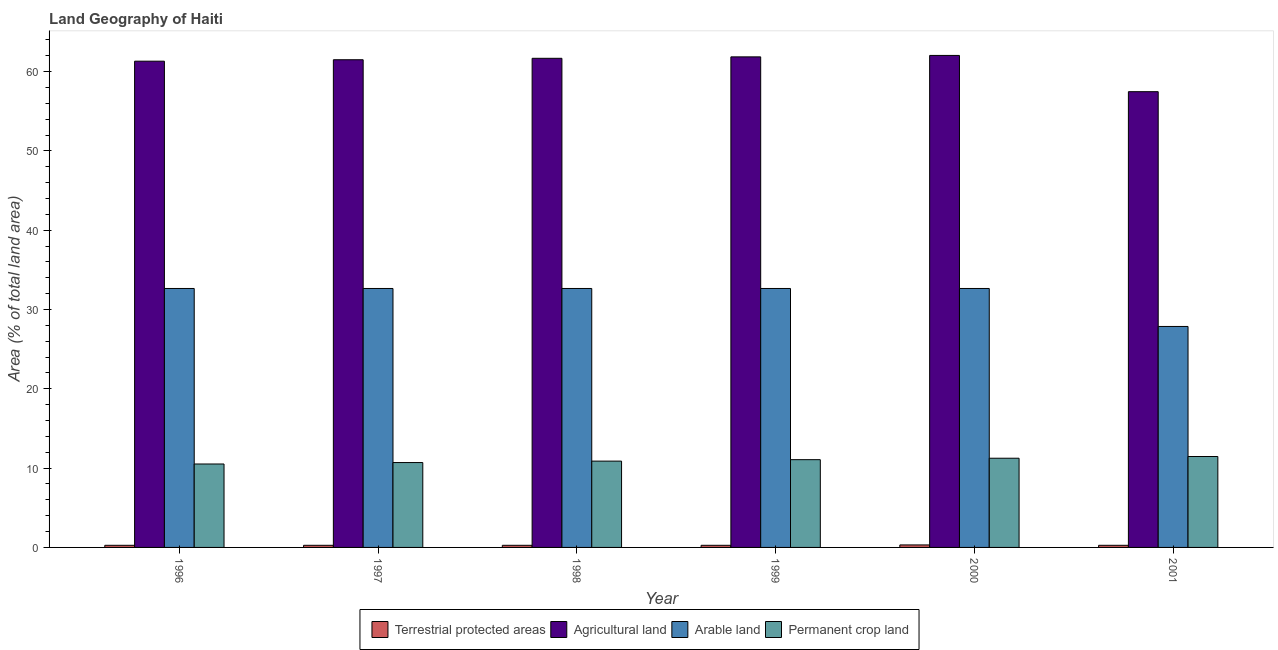How many different coloured bars are there?
Your answer should be very brief. 4. How many bars are there on the 2nd tick from the left?
Provide a short and direct response. 4. How many bars are there on the 5th tick from the right?
Provide a short and direct response. 4. In how many cases, is the number of bars for a given year not equal to the number of legend labels?
Your answer should be very brief. 0. What is the percentage of area under arable land in 1996?
Provide a short and direct response. 32.66. Across all years, what is the maximum percentage of area under agricultural land?
Make the answer very short. 62.05. Across all years, what is the minimum percentage of area under agricultural land?
Provide a succinct answer. 57.47. In which year was the percentage of area under agricultural land maximum?
Your answer should be compact. 2000. In which year was the percentage of land under terrestrial protection minimum?
Provide a succinct answer. 1996. What is the total percentage of land under terrestrial protection in the graph?
Give a very brief answer. 1.66. What is the difference between the percentage of area under permanent crop land in 1999 and that in 2000?
Give a very brief answer. -0.18. What is the difference between the percentage of area under permanent crop land in 1997 and the percentage of area under agricultural land in 2001?
Your response must be concise. -0.76. What is the average percentage of area under arable land per year?
Offer a terse response. 31.86. What is the ratio of the percentage of area under permanent crop land in 1997 to that in 2001?
Provide a short and direct response. 0.93. Is the percentage of land under terrestrial protection in 1996 less than that in 1998?
Provide a succinct answer. No. Is the difference between the percentage of area under arable land in 1999 and 2000 greater than the difference between the percentage of area under permanent crop land in 1999 and 2000?
Keep it short and to the point. No. What is the difference between the highest and the second highest percentage of area under arable land?
Keep it short and to the point. 0. What is the difference between the highest and the lowest percentage of area under arable land?
Give a very brief answer. 4.79. Is it the case that in every year, the sum of the percentage of area under permanent crop land and percentage of area under arable land is greater than the sum of percentage of area under agricultural land and percentage of land under terrestrial protection?
Provide a short and direct response. No. What does the 1st bar from the left in 1998 represents?
Keep it short and to the point. Terrestrial protected areas. What does the 1st bar from the right in 1997 represents?
Offer a terse response. Permanent crop land. Is it the case that in every year, the sum of the percentage of land under terrestrial protection and percentage of area under agricultural land is greater than the percentage of area under arable land?
Provide a succinct answer. Yes. Are all the bars in the graph horizontal?
Make the answer very short. No. What is the difference between two consecutive major ticks on the Y-axis?
Provide a succinct answer. 10. Does the graph contain any zero values?
Ensure brevity in your answer.  No. Does the graph contain grids?
Ensure brevity in your answer.  No. Where does the legend appear in the graph?
Ensure brevity in your answer.  Bottom center. What is the title of the graph?
Offer a very short reply. Land Geography of Haiti. Does "Others" appear as one of the legend labels in the graph?
Your answer should be compact. No. What is the label or title of the Y-axis?
Ensure brevity in your answer.  Area (% of total land area). What is the Area (% of total land area) in Terrestrial protected areas in 1996?
Your answer should be compact. 0.27. What is the Area (% of total land area) in Agricultural land in 1996?
Provide a succinct answer. 61.32. What is the Area (% of total land area) of Arable land in 1996?
Provide a succinct answer. 32.66. What is the Area (% of total land area) of Permanent crop land in 1996?
Make the answer very short. 10.52. What is the Area (% of total land area) in Terrestrial protected areas in 1997?
Provide a succinct answer. 0.27. What is the Area (% of total land area) of Agricultural land in 1997?
Ensure brevity in your answer.  61.5. What is the Area (% of total land area) in Arable land in 1997?
Provide a succinct answer. 32.66. What is the Area (% of total land area) in Permanent crop land in 1997?
Offer a very short reply. 10.7. What is the Area (% of total land area) in Terrestrial protected areas in 1998?
Keep it short and to the point. 0.27. What is the Area (% of total land area) in Agricultural land in 1998?
Provide a short and direct response. 61.68. What is the Area (% of total land area) of Arable land in 1998?
Provide a succinct answer. 32.66. What is the Area (% of total land area) of Permanent crop land in 1998?
Offer a terse response. 10.89. What is the Area (% of total land area) of Terrestrial protected areas in 1999?
Make the answer very short. 0.27. What is the Area (% of total land area) of Agricultural land in 1999?
Offer a very short reply. 61.87. What is the Area (% of total land area) in Arable land in 1999?
Your response must be concise. 32.66. What is the Area (% of total land area) in Permanent crop land in 1999?
Offer a very short reply. 11.07. What is the Area (% of total land area) in Terrestrial protected areas in 2000?
Keep it short and to the point. 0.32. What is the Area (% of total land area) in Agricultural land in 2000?
Provide a short and direct response. 62.05. What is the Area (% of total land area) of Arable land in 2000?
Make the answer very short. 32.66. What is the Area (% of total land area) of Permanent crop land in 2000?
Ensure brevity in your answer.  11.25. What is the Area (% of total land area) in Terrestrial protected areas in 2001?
Ensure brevity in your answer.  0.27. What is the Area (% of total land area) of Agricultural land in 2001?
Provide a succinct answer. 57.47. What is the Area (% of total land area) in Arable land in 2001?
Offer a terse response. 27.87. What is the Area (% of total land area) in Permanent crop land in 2001?
Your answer should be very brief. 11.47. Across all years, what is the maximum Area (% of total land area) of Terrestrial protected areas?
Provide a short and direct response. 0.32. Across all years, what is the maximum Area (% of total land area) in Agricultural land?
Provide a short and direct response. 62.05. Across all years, what is the maximum Area (% of total land area) in Arable land?
Give a very brief answer. 32.66. Across all years, what is the maximum Area (% of total land area) in Permanent crop land?
Your answer should be compact. 11.47. Across all years, what is the minimum Area (% of total land area) in Terrestrial protected areas?
Keep it short and to the point. 0.27. Across all years, what is the minimum Area (% of total land area) in Agricultural land?
Provide a succinct answer. 57.47. Across all years, what is the minimum Area (% of total land area) of Arable land?
Provide a short and direct response. 27.87. Across all years, what is the minimum Area (% of total land area) in Permanent crop land?
Offer a very short reply. 10.52. What is the total Area (% of total land area) of Terrestrial protected areas in the graph?
Ensure brevity in your answer.  1.66. What is the total Area (% of total land area) in Agricultural land in the graph?
Your answer should be compact. 365.89. What is the total Area (% of total land area) in Arable land in the graph?
Offer a terse response. 191.15. What is the total Area (% of total land area) in Permanent crop land in the graph?
Offer a very short reply. 65.89. What is the difference between the Area (% of total land area) of Agricultural land in 1996 and that in 1997?
Provide a succinct answer. -0.18. What is the difference between the Area (% of total land area) of Arable land in 1996 and that in 1997?
Keep it short and to the point. 0. What is the difference between the Area (% of total land area) in Permanent crop land in 1996 and that in 1997?
Ensure brevity in your answer.  -0.18. What is the difference between the Area (% of total land area) of Terrestrial protected areas in 1996 and that in 1998?
Make the answer very short. 0. What is the difference between the Area (% of total land area) in Agricultural land in 1996 and that in 1998?
Provide a short and direct response. -0.36. What is the difference between the Area (% of total land area) in Permanent crop land in 1996 and that in 1998?
Your response must be concise. -0.36. What is the difference between the Area (% of total land area) of Agricultural land in 1996 and that in 1999?
Give a very brief answer. -0.54. What is the difference between the Area (% of total land area) in Arable land in 1996 and that in 1999?
Give a very brief answer. 0. What is the difference between the Area (% of total land area) of Permanent crop land in 1996 and that in 1999?
Make the answer very short. -0.54. What is the difference between the Area (% of total land area) of Terrestrial protected areas in 1996 and that in 2000?
Provide a short and direct response. -0.05. What is the difference between the Area (% of total land area) in Agricultural land in 1996 and that in 2000?
Provide a succinct answer. -0.73. What is the difference between the Area (% of total land area) in Permanent crop land in 1996 and that in 2000?
Provide a short and direct response. -0.73. What is the difference between the Area (% of total land area) of Terrestrial protected areas in 1996 and that in 2001?
Provide a short and direct response. 0. What is the difference between the Area (% of total land area) in Agricultural land in 1996 and that in 2001?
Keep it short and to the point. 3.85. What is the difference between the Area (% of total land area) of Arable land in 1996 and that in 2001?
Your answer should be compact. 4.79. What is the difference between the Area (% of total land area) in Permanent crop land in 1996 and that in 2001?
Provide a succinct answer. -0.94. What is the difference between the Area (% of total land area) in Agricultural land in 1997 and that in 1998?
Make the answer very short. -0.18. What is the difference between the Area (% of total land area) of Arable land in 1997 and that in 1998?
Offer a terse response. 0. What is the difference between the Area (% of total land area) of Permanent crop land in 1997 and that in 1998?
Provide a short and direct response. -0.18. What is the difference between the Area (% of total land area) in Agricultural land in 1997 and that in 1999?
Offer a very short reply. -0.36. What is the difference between the Area (% of total land area) of Permanent crop land in 1997 and that in 1999?
Offer a very short reply. -0.36. What is the difference between the Area (% of total land area) of Terrestrial protected areas in 1997 and that in 2000?
Your response must be concise. -0.05. What is the difference between the Area (% of total land area) of Agricultural land in 1997 and that in 2000?
Keep it short and to the point. -0.54. What is the difference between the Area (% of total land area) of Arable land in 1997 and that in 2000?
Provide a short and direct response. 0. What is the difference between the Area (% of total land area) of Permanent crop land in 1997 and that in 2000?
Your response must be concise. -0.54. What is the difference between the Area (% of total land area) of Agricultural land in 1997 and that in 2001?
Offer a very short reply. 4.03. What is the difference between the Area (% of total land area) of Arable land in 1997 and that in 2001?
Offer a terse response. 4.79. What is the difference between the Area (% of total land area) in Permanent crop land in 1997 and that in 2001?
Keep it short and to the point. -0.76. What is the difference between the Area (% of total land area) in Agricultural land in 1998 and that in 1999?
Ensure brevity in your answer.  -0.18. What is the difference between the Area (% of total land area) in Permanent crop land in 1998 and that in 1999?
Provide a short and direct response. -0.18. What is the difference between the Area (% of total land area) in Terrestrial protected areas in 1998 and that in 2000?
Provide a short and direct response. -0.05. What is the difference between the Area (% of total land area) of Agricultural land in 1998 and that in 2000?
Ensure brevity in your answer.  -0.36. What is the difference between the Area (% of total land area) of Arable land in 1998 and that in 2000?
Provide a short and direct response. 0. What is the difference between the Area (% of total land area) of Permanent crop land in 1998 and that in 2000?
Offer a terse response. -0.36. What is the difference between the Area (% of total land area) in Agricultural land in 1998 and that in 2001?
Provide a succinct answer. 4.21. What is the difference between the Area (% of total land area) of Arable land in 1998 and that in 2001?
Keep it short and to the point. 4.79. What is the difference between the Area (% of total land area) of Permanent crop land in 1998 and that in 2001?
Provide a succinct answer. -0.58. What is the difference between the Area (% of total land area) in Terrestrial protected areas in 1999 and that in 2000?
Give a very brief answer. -0.05. What is the difference between the Area (% of total land area) of Agricultural land in 1999 and that in 2000?
Your answer should be compact. -0.18. What is the difference between the Area (% of total land area) of Permanent crop land in 1999 and that in 2000?
Ensure brevity in your answer.  -0.18. What is the difference between the Area (% of total land area) of Agricultural land in 1999 and that in 2001?
Give a very brief answer. 4.39. What is the difference between the Area (% of total land area) in Arable land in 1999 and that in 2001?
Keep it short and to the point. 4.79. What is the difference between the Area (% of total land area) in Permanent crop land in 1999 and that in 2001?
Your answer should be very brief. -0.4. What is the difference between the Area (% of total land area) of Terrestrial protected areas in 2000 and that in 2001?
Provide a short and direct response. 0.05. What is the difference between the Area (% of total land area) of Agricultural land in 2000 and that in 2001?
Make the answer very short. 4.57. What is the difference between the Area (% of total land area) of Arable land in 2000 and that in 2001?
Ensure brevity in your answer.  4.79. What is the difference between the Area (% of total land area) of Permanent crop land in 2000 and that in 2001?
Your answer should be very brief. -0.22. What is the difference between the Area (% of total land area) in Terrestrial protected areas in 1996 and the Area (% of total land area) in Agricultural land in 1997?
Your response must be concise. -61.23. What is the difference between the Area (% of total land area) of Terrestrial protected areas in 1996 and the Area (% of total land area) of Arable land in 1997?
Provide a short and direct response. -32.39. What is the difference between the Area (% of total land area) of Terrestrial protected areas in 1996 and the Area (% of total land area) of Permanent crop land in 1997?
Offer a very short reply. -10.44. What is the difference between the Area (% of total land area) in Agricultural land in 1996 and the Area (% of total land area) in Arable land in 1997?
Make the answer very short. 28.66. What is the difference between the Area (% of total land area) of Agricultural land in 1996 and the Area (% of total land area) of Permanent crop land in 1997?
Your response must be concise. 50.62. What is the difference between the Area (% of total land area) of Arable land in 1996 and the Area (% of total land area) of Permanent crop land in 1997?
Your answer should be very brief. 21.95. What is the difference between the Area (% of total land area) in Terrestrial protected areas in 1996 and the Area (% of total land area) in Agricultural land in 1998?
Offer a very short reply. -61.42. What is the difference between the Area (% of total land area) in Terrestrial protected areas in 1996 and the Area (% of total land area) in Arable land in 1998?
Ensure brevity in your answer.  -32.39. What is the difference between the Area (% of total land area) of Terrestrial protected areas in 1996 and the Area (% of total land area) of Permanent crop land in 1998?
Keep it short and to the point. -10.62. What is the difference between the Area (% of total land area) in Agricultural land in 1996 and the Area (% of total land area) in Arable land in 1998?
Your answer should be compact. 28.66. What is the difference between the Area (% of total land area) of Agricultural land in 1996 and the Area (% of total land area) of Permanent crop land in 1998?
Your answer should be compact. 50.44. What is the difference between the Area (% of total land area) in Arable land in 1996 and the Area (% of total land area) in Permanent crop land in 1998?
Offer a very short reply. 21.77. What is the difference between the Area (% of total land area) in Terrestrial protected areas in 1996 and the Area (% of total land area) in Agricultural land in 1999?
Offer a very short reply. -61.6. What is the difference between the Area (% of total land area) of Terrestrial protected areas in 1996 and the Area (% of total land area) of Arable land in 1999?
Keep it short and to the point. -32.39. What is the difference between the Area (% of total land area) of Terrestrial protected areas in 1996 and the Area (% of total land area) of Permanent crop land in 1999?
Ensure brevity in your answer.  -10.8. What is the difference between the Area (% of total land area) in Agricultural land in 1996 and the Area (% of total land area) in Arable land in 1999?
Provide a short and direct response. 28.66. What is the difference between the Area (% of total land area) of Agricultural land in 1996 and the Area (% of total land area) of Permanent crop land in 1999?
Make the answer very short. 50.25. What is the difference between the Area (% of total land area) in Arable land in 1996 and the Area (% of total land area) in Permanent crop land in 1999?
Offer a very short reply. 21.59. What is the difference between the Area (% of total land area) in Terrestrial protected areas in 1996 and the Area (% of total land area) in Agricultural land in 2000?
Give a very brief answer. -61.78. What is the difference between the Area (% of total land area) in Terrestrial protected areas in 1996 and the Area (% of total land area) in Arable land in 2000?
Give a very brief answer. -32.39. What is the difference between the Area (% of total land area) of Terrestrial protected areas in 1996 and the Area (% of total land area) of Permanent crop land in 2000?
Provide a succinct answer. -10.98. What is the difference between the Area (% of total land area) of Agricultural land in 1996 and the Area (% of total land area) of Arable land in 2000?
Provide a succinct answer. 28.66. What is the difference between the Area (% of total land area) in Agricultural land in 1996 and the Area (% of total land area) in Permanent crop land in 2000?
Provide a short and direct response. 50.07. What is the difference between the Area (% of total land area) in Arable land in 1996 and the Area (% of total land area) in Permanent crop land in 2000?
Make the answer very short. 21.41. What is the difference between the Area (% of total land area) of Terrestrial protected areas in 1996 and the Area (% of total land area) of Agricultural land in 2001?
Keep it short and to the point. -57.21. What is the difference between the Area (% of total land area) in Terrestrial protected areas in 1996 and the Area (% of total land area) in Arable land in 2001?
Give a very brief answer. -27.6. What is the difference between the Area (% of total land area) in Terrestrial protected areas in 1996 and the Area (% of total land area) in Permanent crop land in 2001?
Offer a very short reply. -11.2. What is the difference between the Area (% of total land area) in Agricultural land in 1996 and the Area (% of total land area) in Arable land in 2001?
Ensure brevity in your answer.  33.45. What is the difference between the Area (% of total land area) in Agricultural land in 1996 and the Area (% of total land area) in Permanent crop land in 2001?
Your answer should be very brief. 49.85. What is the difference between the Area (% of total land area) in Arable land in 1996 and the Area (% of total land area) in Permanent crop land in 2001?
Offer a terse response. 21.19. What is the difference between the Area (% of total land area) of Terrestrial protected areas in 1997 and the Area (% of total land area) of Agricultural land in 1998?
Your answer should be very brief. -61.42. What is the difference between the Area (% of total land area) of Terrestrial protected areas in 1997 and the Area (% of total land area) of Arable land in 1998?
Provide a short and direct response. -32.39. What is the difference between the Area (% of total land area) in Terrestrial protected areas in 1997 and the Area (% of total land area) in Permanent crop land in 1998?
Ensure brevity in your answer.  -10.62. What is the difference between the Area (% of total land area) of Agricultural land in 1997 and the Area (% of total land area) of Arable land in 1998?
Provide a short and direct response. 28.85. What is the difference between the Area (% of total land area) of Agricultural land in 1997 and the Area (% of total land area) of Permanent crop land in 1998?
Your answer should be very brief. 50.62. What is the difference between the Area (% of total land area) in Arable land in 1997 and the Area (% of total land area) in Permanent crop land in 1998?
Offer a very short reply. 21.77. What is the difference between the Area (% of total land area) in Terrestrial protected areas in 1997 and the Area (% of total land area) in Agricultural land in 1999?
Keep it short and to the point. -61.6. What is the difference between the Area (% of total land area) of Terrestrial protected areas in 1997 and the Area (% of total land area) of Arable land in 1999?
Give a very brief answer. -32.39. What is the difference between the Area (% of total land area) in Terrestrial protected areas in 1997 and the Area (% of total land area) in Permanent crop land in 1999?
Make the answer very short. -10.8. What is the difference between the Area (% of total land area) in Agricultural land in 1997 and the Area (% of total land area) in Arable land in 1999?
Your answer should be compact. 28.85. What is the difference between the Area (% of total land area) of Agricultural land in 1997 and the Area (% of total land area) of Permanent crop land in 1999?
Your answer should be very brief. 50.44. What is the difference between the Area (% of total land area) of Arable land in 1997 and the Area (% of total land area) of Permanent crop land in 1999?
Your answer should be compact. 21.59. What is the difference between the Area (% of total land area) of Terrestrial protected areas in 1997 and the Area (% of total land area) of Agricultural land in 2000?
Provide a succinct answer. -61.78. What is the difference between the Area (% of total land area) in Terrestrial protected areas in 1997 and the Area (% of total land area) in Arable land in 2000?
Your answer should be compact. -32.39. What is the difference between the Area (% of total land area) in Terrestrial protected areas in 1997 and the Area (% of total land area) in Permanent crop land in 2000?
Offer a terse response. -10.98. What is the difference between the Area (% of total land area) of Agricultural land in 1997 and the Area (% of total land area) of Arable land in 2000?
Offer a very short reply. 28.85. What is the difference between the Area (% of total land area) of Agricultural land in 1997 and the Area (% of total land area) of Permanent crop land in 2000?
Your answer should be compact. 50.25. What is the difference between the Area (% of total land area) in Arable land in 1997 and the Area (% of total land area) in Permanent crop land in 2000?
Provide a short and direct response. 21.41. What is the difference between the Area (% of total land area) of Terrestrial protected areas in 1997 and the Area (% of total land area) of Agricultural land in 2001?
Provide a short and direct response. -57.21. What is the difference between the Area (% of total land area) in Terrestrial protected areas in 1997 and the Area (% of total land area) in Arable land in 2001?
Provide a succinct answer. -27.6. What is the difference between the Area (% of total land area) of Terrestrial protected areas in 1997 and the Area (% of total land area) of Permanent crop land in 2001?
Make the answer very short. -11.2. What is the difference between the Area (% of total land area) of Agricultural land in 1997 and the Area (% of total land area) of Arable land in 2001?
Give a very brief answer. 33.64. What is the difference between the Area (% of total land area) of Agricultural land in 1997 and the Area (% of total land area) of Permanent crop land in 2001?
Give a very brief answer. 50.04. What is the difference between the Area (% of total land area) of Arable land in 1997 and the Area (% of total land area) of Permanent crop land in 2001?
Provide a succinct answer. 21.19. What is the difference between the Area (% of total land area) in Terrestrial protected areas in 1998 and the Area (% of total land area) in Agricultural land in 1999?
Your response must be concise. -61.6. What is the difference between the Area (% of total land area) in Terrestrial protected areas in 1998 and the Area (% of total land area) in Arable land in 1999?
Offer a terse response. -32.39. What is the difference between the Area (% of total land area) in Terrestrial protected areas in 1998 and the Area (% of total land area) in Permanent crop land in 1999?
Ensure brevity in your answer.  -10.8. What is the difference between the Area (% of total land area) of Agricultural land in 1998 and the Area (% of total land area) of Arable land in 1999?
Make the answer very short. 29.03. What is the difference between the Area (% of total land area) in Agricultural land in 1998 and the Area (% of total land area) in Permanent crop land in 1999?
Provide a short and direct response. 50.62. What is the difference between the Area (% of total land area) of Arable land in 1998 and the Area (% of total land area) of Permanent crop land in 1999?
Your answer should be very brief. 21.59. What is the difference between the Area (% of total land area) of Terrestrial protected areas in 1998 and the Area (% of total land area) of Agricultural land in 2000?
Provide a succinct answer. -61.78. What is the difference between the Area (% of total land area) of Terrestrial protected areas in 1998 and the Area (% of total land area) of Arable land in 2000?
Provide a succinct answer. -32.39. What is the difference between the Area (% of total land area) in Terrestrial protected areas in 1998 and the Area (% of total land area) in Permanent crop land in 2000?
Keep it short and to the point. -10.98. What is the difference between the Area (% of total land area) of Agricultural land in 1998 and the Area (% of total land area) of Arable land in 2000?
Your response must be concise. 29.03. What is the difference between the Area (% of total land area) of Agricultural land in 1998 and the Area (% of total land area) of Permanent crop land in 2000?
Your answer should be compact. 50.44. What is the difference between the Area (% of total land area) of Arable land in 1998 and the Area (% of total land area) of Permanent crop land in 2000?
Your answer should be very brief. 21.41. What is the difference between the Area (% of total land area) in Terrestrial protected areas in 1998 and the Area (% of total land area) in Agricultural land in 2001?
Your answer should be compact. -57.21. What is the difference between the Area (% of total land area) of Terrestrial protected areas in 1998 and the Area (% of total land area) of Arable land in 2001?
Offer a very short reply. -27.6. What is the difference between the Area (% of total land area) in Terrestrial protected areas in 1998 and the Area (% of total land area) in Permanent crop land in 2001?
Make the answer very short. -11.2. What is the difference between the Area (% of total land area) of Agricultural land in 1998 and the Area (% of total land area) of Arable land in 2001?
Your answer should be compact. 33.82. What is the difference between the Area (% of total land area) of Agricultural land in 1998 and the Area (% of total land area) of Permanent crop land in 2001?
Provide a short and direct response. 50.22. What is the difference between the Area (% of total land area) in Arable land in 1998 and the Area (% of total land area) in Permanent crop land in 2001?
Make the answer very short. 21.19. What is the difference between the Area (% of total land area) of Terrestrial protected areas in 1999 and the Area (% of total land area) of Agricultural land in 2000?
Make the answer very short. -61.78. What is the difference between the Area (% of total land area) in Terrestrial protected areas in 1999 and the Area (% of total land area) in Arable land in 2000?
Offer a very short reply. -32.39. What is the difference between the Area (% of total land area) in Terrestrial protected areas in 1999 and the Area (% of total land area) in Permanent crop land in 2000?
Your answer should be compact. -10.98. What is the difference between the Area (% of total land area) in Agricultural land in 1999 and the Area (% of total land area) in Arable land in 2000?
Your response must be concise. 29.21. What is the difference between the Area (% of total land area) in Agricultural land in 1999 and the Area (% of total land area) in Permanent crop land in 2000?
Give a very brief answer. 50.62. What is the difference between the Area (% of total land area) of Arable land in 1999 and the Area (% of total land area) of Permanent crop land in 2000?
Your response must be concise. 21.41. What is the difference between the Area (% of total land area) in Terrestrial protected areas in 1999 and the Area (% of total land area) in Agricultural land in 2001?
Ensure brevity in your answer.  -57.21. What is the difference between the Area (% of total land area) in Terrestrial protected areas in 1999 and the Area (% of total land area) in Arable land in 2001?
Your answer should be very brief. -27.6. What is the difference between the Area (% of total land area) of Terrestrial protected areas in 1999 and the Area (% of total land area) of Permanent crop land in 2001?
Offer a terse response. -11.2. What is the difference between the Area (% of total land area) of Agricultural land in 1999 and the Area (% of total land area) of Arable land in 2001?
Make the answer very short. 34. What is the difference between the Area (% of total land area) of Agricultural land in 1999 and the Area (% of total land area) of Permanent crop land in 2001?
Your answer should be very brief. 50.4. What is the difference between the Area (% of total land area) in Arable land in 1999 and the Area (% of total land area) in Permanent crop land in 2001?
Offer a terse response. 21.19. What is the difference between the Area (% of total land area) of Terrestrial protected areas in 2000 and the Area (% of total land area) of Agricultural land in 2001?
Give a very brief answer. -57.16. What is the difference between the Area (% of total land area) of Terrestrial protected areas in 2000 and the Area (% of total land area) of Arable land in 2001?
Ensure brevity in your answer.  -27.55. What is the difference between the Area (% of total land area) of Terrestrial protected areas in 2000 and the Area (% of total land area) of Permanent crop land in 2001?
Offer a terse response. -11.15. What is the difference between the Area (% of total land area) in Agricultural land in 2000 and the Area (% of total land area) in Arable land in 2001?
Offer a terse response. 34.18. What is the difference between the Area (% of total land area) in Agricultural land in 2000 and the Area (% of total land area) in Permanent crop land in 2001?
Give a very brief answer. 50.58. What is the difference between the Area (% of total land area) of Arable land in 2000 and the Area (% of total land area) of Permanent crop land in 2001?
Make the answer very short. 21.19. What is the average Area (% of total land area) in Terrestrial protected areas per year?
Keep it short and to the point. 0.28. What is the average Area (% of total land area) of Agricultural land per year?
Your answer should be very brief. 60.98. What is the average Area (% of total land area) of Arable land per year?
Your response must be concise. 31.86. What is the average Area (% of total land area) of Permanent crop land per year?
Keep it short and to the point. 10.98. In the year 1996, what is the difference between the Area (% of total land area) of Terrestrial protected areas and Area (% of total land area) of Agricultural land?
Your answer should be compact. -61.05. In the year 1996, what is the difference between the Area (% of total land area) in Terrestrial protected areas and Area (% of total land area) in Arable land?
Keep it short and to the point. -32.39. In the year 1996, what is the difference between the Area (% of total land area) of Terrestrial protected areas and Area (% of total land area) of Permanent crop land?
Provide a short and direct response. -10.25. In the year 1996, what is the difference between the Area (% of total land area) in Agricultural land and Area (% of total land area) in Arable land?
Your response must be concise. 28.66. In the year 1996, what is the difference between the Area (% of total land area) in Agricultural land and Area (% of total land area) in Permanent crop land?
Your response must be concise. 50.8. In the year 1996, what is the difference between the Area (% of total land area) in Arable land and Area (% of total land area) in Permanent crop land?
Keep it short and to the point. 22.13. In the year 1997, what is the difference between the Area (% of total land area) of Terrestrial protected areas and Area (% of total land area) of Agricultural land?
Provide a succinct answer. -61.23. In the year 1997, what is the difference between the Area (% of total land area) of Terrestrial protected areas and Area (% of total land area) of Arable land?
Ensure brevity in your answer.  -32.39. In the year 1997, what is the difference between the Area (% of total land area) in Terrestrial protected areas and Area (% of total land area) in Permanent crop land?
Keep it short and to the point. -10.44. In the year 1997, what is the difference between the Area (% of total land area) in Agricultural land and Area (% of total land area) in Arable land?
Keep it short and to the point. 28.85. In the year 1997, what is the difference between the Area (% of total land area) of Agricultural land and Area (% of total land area) of Permanent crop land?
Your answer should be very brief. 50.8. In the year 1997, what is the difference between the Area (% of total land area) in Arable land and Area (% of total land area) in Permanent crop land?
Make the answer very short. 21.95. In the year 1998, what is the difference between the Area (% of total land area) of Terrestrial protected areas and Area (% of total land area) of Agricultural land?
Offer a terse response. -61.42. In the year 1998, what is the difference between the Area (% of total land area) of Terrestrial protected areas and Area (% of total land area) of Arable land?
Ensure brevity in your answer.  -32.39. In the year 1998, what is the difference between the Area (% of total land area) in Terrestrial protected areas and Area (% of total land area) in Permanent crop land?
Provide a short and direct response. -10.62. In the year 1998, what is the difference between the Area (% of total land area) in Agricultural land and Area (% of total land area) in Arable land?
Your answer should be compact. 29.03. In the year 1998, what is the difference between the Area (% of total land area) of Agricultural land and Area (% of total land area) of Permanent crop land?
Offer a terse response. 50.8. In the year 1998, what is the difference between the Area (% of total land area) of Arable land and Area (% of total land area) of Permanent crop land?
Offer a terse response. 21.77. In the year 1999, what is the difference between the Area (% of total land area) in Terrestrial protected areas and Area (% of total land area) in Agricultural land?
Give a very brief answer. -61.6. In the year 1999, what is the difference between the Area (% of total land area) of Terrestrial protected areas and Area (% of total land area) of Arable land?
Your response must be concise. -32.39. In the year 1999, what is the difference between the Area (% of total land area) in Terrestrial protected areas and Area (% of total land area) in Permanent crop land?
Make the answer very short. -10.8. In the year 1999, what is the difference between the Area (% of total land area) of Agricultural land and Area (% of total land area) of Arable land?
Provide a succinct answer. 29.21. In the year 1999, what is the difference between the Area (% of total land area) of Agricultural land and Area (% of total land area) of Permanent crop land?
Your answer should be compact. 50.8. In the year 1999, what is the difference between the Area (% of total land area) in Arable land and Area (% of total land area) in Permanent crop land?
Offer a terse response. 21.59. In the year 2000, what is the difference between the Area (% of total land area) of Terrestrial protected areas and Area (% of total land area) of Agricultural land?
Your answer should be very brief. -61.73. In the year 2000, what is the difference between the Area (% of total land area) of Terrestrial protected areas and Area (% of total land area) of Arable land?
Offer a terse response. -32.34. In the year 2000, what is the difference between the Area (% of total land area) in Terrestrial protected areas and Area (% of total land area) in Permanent crop land?
Your answer should be very brief. -10.93. In the year 2000, what is the difference between the Area (% of total land area) of Agricultural land and Area (% of total land area) of Arable land?
Give a very brief answer. 29.39. In the year 2000, what is the difference between the Area (% of total land area) in Agricultural land and Area (% of total land area) in Permanent crop land?
Keep it short and to the point. 50.8. In the year 2000, what is the difference between the Area (% of total land area) in Arable land and Area (% of total land area) in Permanent crop land?
Provide a succinct answer. 21.41. In the year 2001, what is the difference between the Area (% of total land area) in Terrestrial protected areas and Area (% of total land area) in Agricultural land?
Keep it short and to the point. -57.21. In the year 2001, what is the difference between the Area (% of total land area) in Terrestrial protected areas and Area (% of total land area) in Arable land?
Make the answer very short. -27.6. In the year 2001, what is the difference between the Area (% of total land area) in Terrestrial protected areas and Area (% of total land area) in Permanent crop land?
Give a very brief answer. -11.2. In the year 2001, what is the difference between the Area (% of total land area) of Agricultural land and Area (% of total land area) of Arable land?
Ensure brevity in your answer.  29.61. In the year 2001, what is the difference between the Area (% of total land area) in Agricultural land and Area (% of total land area) in Permanent crop land?
Provide a succinct answer. 46.01. In the year 2001, what is the difference between the Area (% of total land area) in Arable land and Area (% of total land area) in Permanent crop land?
Ensure brevity in your answer.  16.4. What is the ratio of the Area (% of total land area) of Agricultural land in 1996 to that in 1997?
Your response must be concise. 1. What is the ratio of the Area (% of total land area) in Permanent crop land in 1996 to that in 1997?
Your answer should be compact. 0.98. What is the ratio of the Area (% of total land area) in Terrestrial protected areas in 1996 to that in 1998?
Your answer should be very brief. 1. What is the ratio of the Area (% of total land area) in Permanent crop land in 1996 to that in 1998?
Make the answer very short. 0.97. What is the ratio of the Area (% of total land area) in Terrestrial protected areas in 1996 to that in 1999?
Keep it short and to the point. 1. What is the ratio of the Area (% of total land area) of Arable land in 1996 to that in 1999?
Your answer should be very brief. 1. What is the ratio of the Area (% of total land area) of Permanent crop land in 1996 to that in 1999?
Provide a short and direct response. 0.95. What is the ratio of the Area (% of total land area) in Terrestrial protected areas in 1996 to that in 2000?
Your answer should be compact. 0.85. What is the ratio of the Area (% of total land area) in Agricultural land in 1996 to that in 2000?
Offer a terse response. 0.99. What is the ratio of the Area (% of total land area) in Permanent crop land in 1996 to that in 2000?
Ensure brevity in your answer.  0.94. What is the ratio of the Area (% of total land area) of Agricultural land in 1996 to that in 2001?
Give a very brief answer. 1.07. What is the ratio of the Area (% of total land area) in Arable land in 1996 to that in 2001?
Make the answer very short. 1.17. What is the ratio of the Area (% of total land area) in Permanent crop land in 1996 to that in 2001?
Make the answer very short. 0.92. What is the ratio of the Area (% of total land area) of Terrestrial protected areas in 1997 to that in 1998?
Make the answer very short. 1. What is the ratio of the Area (% of total land area) of Agricultural land in 1997 to that in 1998?
Provide a succinct answer. 1. What is the ratio of the Area (% of total land area) of Permanent crop land in 1997 to that in 1998?
Provide a short and direct response. 0.98. What is the ratio of the Area (% of total land area) of Permanent crop land in 1997 to that in 1999?
Provide a succinct answer. 0.97. What is the ratio of the Area (% of total land area) in Terrestrial protected areas in 1997 to that in 2000?
Make the answer very short. 0.85. What is the ratio of the Area (% of total land area) of Arable land in 1997 to that in 2000?
Your answer should be compact. 1. What is the ratio of the Area (% of total land area) in Permanent crop land in 1997 to that in 2000?
Make the answer very short. 0.95. What is the ratio of the Area (% of total land area) of Terrestrial protected areas in 1997 to that in 2001?
Your answer should be very brief. 1. What is the ratio of the Area (% of total land area) in Agricultural land in 1997 to that in 2001?
Your response must be concise. 1.07. What is the ratio of the Area (% of total land area) of Arable land in 1997 to that in 2001?
Offer a terse response. 1.17. What is the ratio of the Area (% of total land area) in Permanent crop land in 1997 to that in 2001?
Ensure brevity in your answer.  0.93. What is the ratio of the Area (% of total land area) of Terrestrial protected areas in 1998 to that in 1999?
Keep it short and to the point. 1. What is the ratio of the Area (% of total land area) of Arable land in 1998 to that in 1999?
Offer a terse response. 1. What is the ratio of the Area (% of total land area) of Permanent crop land in 1998 to that in 1999?
Provide a short and direct response. 0.98. What is the ratio of the Area (% of total land area) of Terrestrial protected areas in 1998 to that in 2000?
Your response must be concise. 0.85. What is the ratio of the Area (% of total land area) in Permanent crop land in 1998 to that in 2000?
Provide a short and direct response. 0.97. What is the ratio of the Area (% of total land area) of Agricultural land in 1998 to that in 2001?
Make the answer very short. 1.07. What is the ratio of the Area (% of total land area) in Arable land in 1998 to that in 2001?
Ensure brevity in your answer.  1.17. What is the ratio of the Area (% of total land area) of Permanent crop land in 1998 to that in 2001?
Your response must be concise. 0.95. What is the ratio of the Area (% of total land area) of Terrestrial protected areas in 1999 to that in 2000?
Keep it short and to the point. 0.85. What is the ratio of the Area (% of total land area) in Permanent crop land in 1999 to that in 2000?
Offer a very short reply. 0.98. What is the ratio of the Area (% of total land area) in Terrestrial protected areas in 1999 to that in 2001?
Offer a very short reply. 1. What is the ratio of the Area (% of total land area) of Agricultural land in 1999 to that in 2001?
Provide a succinct answer. 1.08. What is the ratio of the Area (% of total land area) in Arable land in 1999 to that in 2001?
Offer a very short reply. 1.17. What is the ratio of the Area (% of total land area) of Permanent crop land in 1999 to that in 2001?
Your response must be concise. 0.97. What is the ratio of the Area (% of total land area) in Terrestrial protected areas in 2000 to that in 2001?
Provide a succinct answer. 1.18. What is the ratio of the Area (% of total land area) of Agricultural land in 2000 to that in 2001?
Ensure brevity in your answer.  1.08. What is the ratio of the Area (% of total land area) in Arable land in 2000 to that in 2001?
Give a very brief answer. 1.17. What is the ratio of the Area (% of total land area) of Permanent crop land in 2000 to that in 2001?
Your response must be concise. 0.98. What is the difference between the highest and the second highest Area (% of total land area) of Terrestrial protected areas?
Give a very brief answer. 0.05. What is the difference between the highest and the second highest Area (% of total land area) in Agricultural land?
Make the answer very short. 0.18. What is the difference between the highest and the second highest Area (% of total land area) in Permanent crop land?
Keep it short and to the point. 0.22. What is the difference between the highest and the lowest Area (% of total land area) of Terrestrial protected areas?
Provide a short and direct response. 0.05. What is the difference between the highest and the lowest Area (% of total land area) of Agricultural land?
Ensure brevity in your answer.  4.57. What is the difference between the highest and the lowest Area (% of total land area) of Arable land?
Your answer should be very brief. 4.79. What is the difference between the highest and the lowest Area (% of total land area) of Permanent crop land?
Your answer should be very brief. 0.94. 